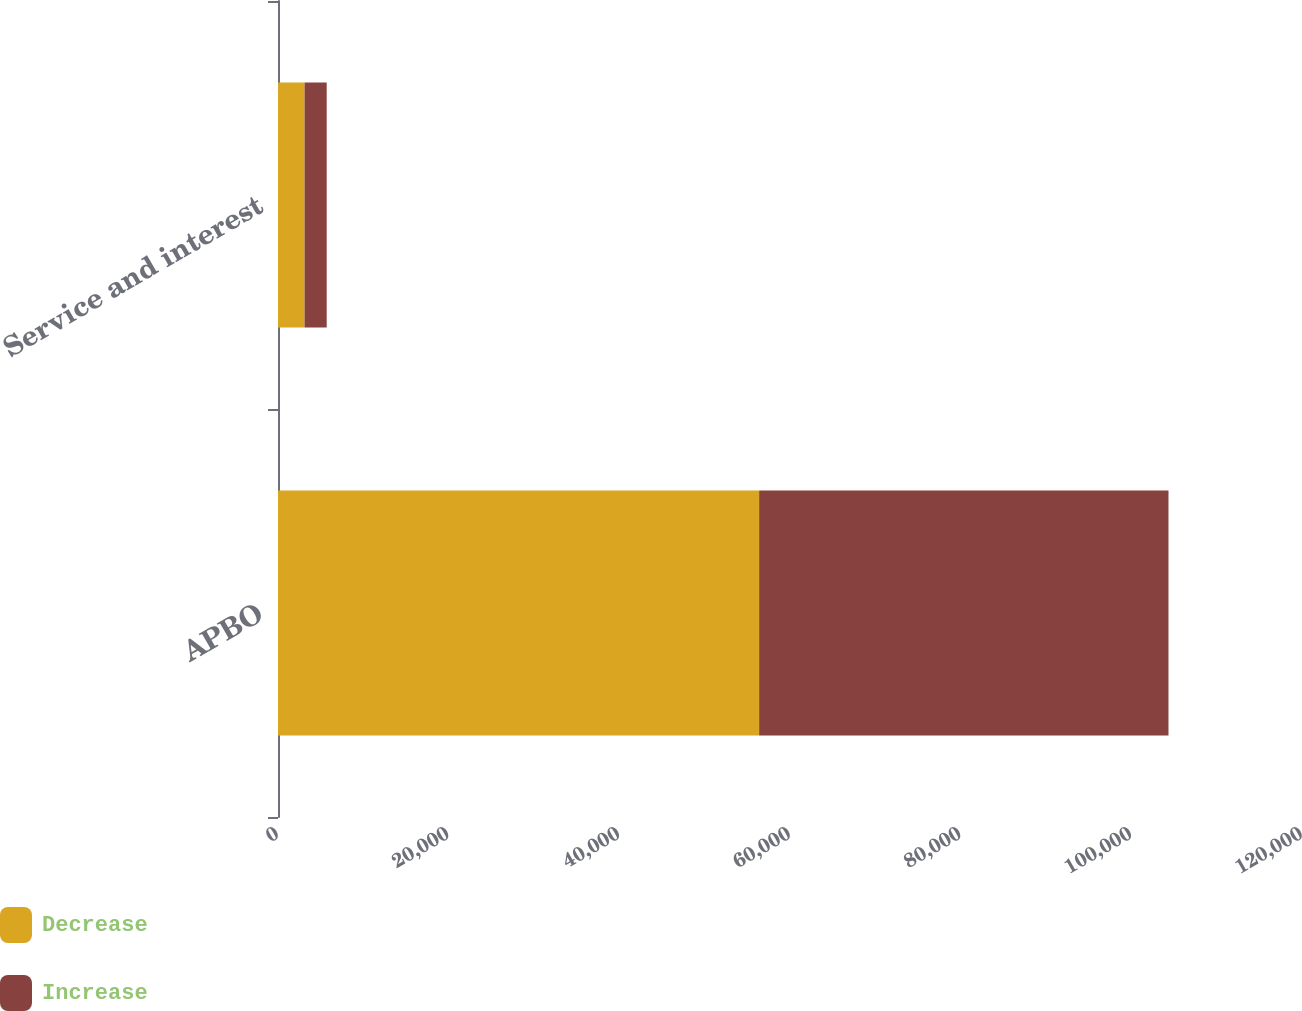<chart> <loc_0><loc_0><loc_500><loc_500><stacked_bar_chart><ecel><fcel>APBO<fcel>Service and interest<nl><fcel>Decrease<fcel>56383<fcel>3113<nl><fcel>Increase<fcel>47972<fcel>2594<nl></chart> 